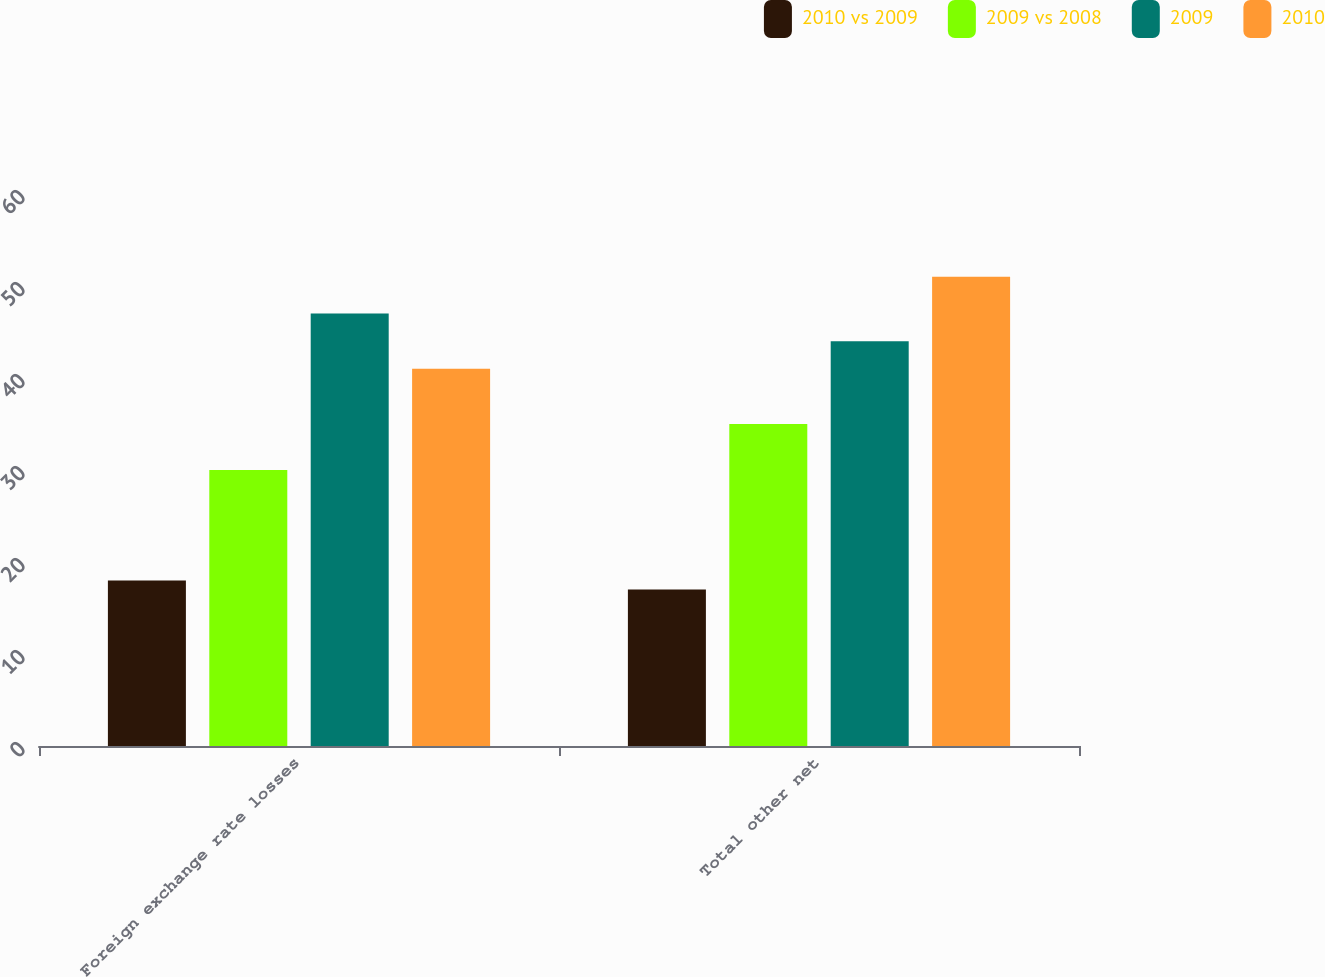Convert chart. <chart><loc_0><loc_0><loc_500><loc_500><stacked_bar_chart><ecel><fcel>Foreign exchange rate losses<fcel>Total other net<nl><fcel>2010 vs 2009<fcel>18<fcel>17<nl><fcel>2009 vs 2008<fcel>30<fcel>35<nl><fcel>2009<fcel>47<fcel>44<nl><fcel>2010<fcel>41<fcel>51<nl></chart> 